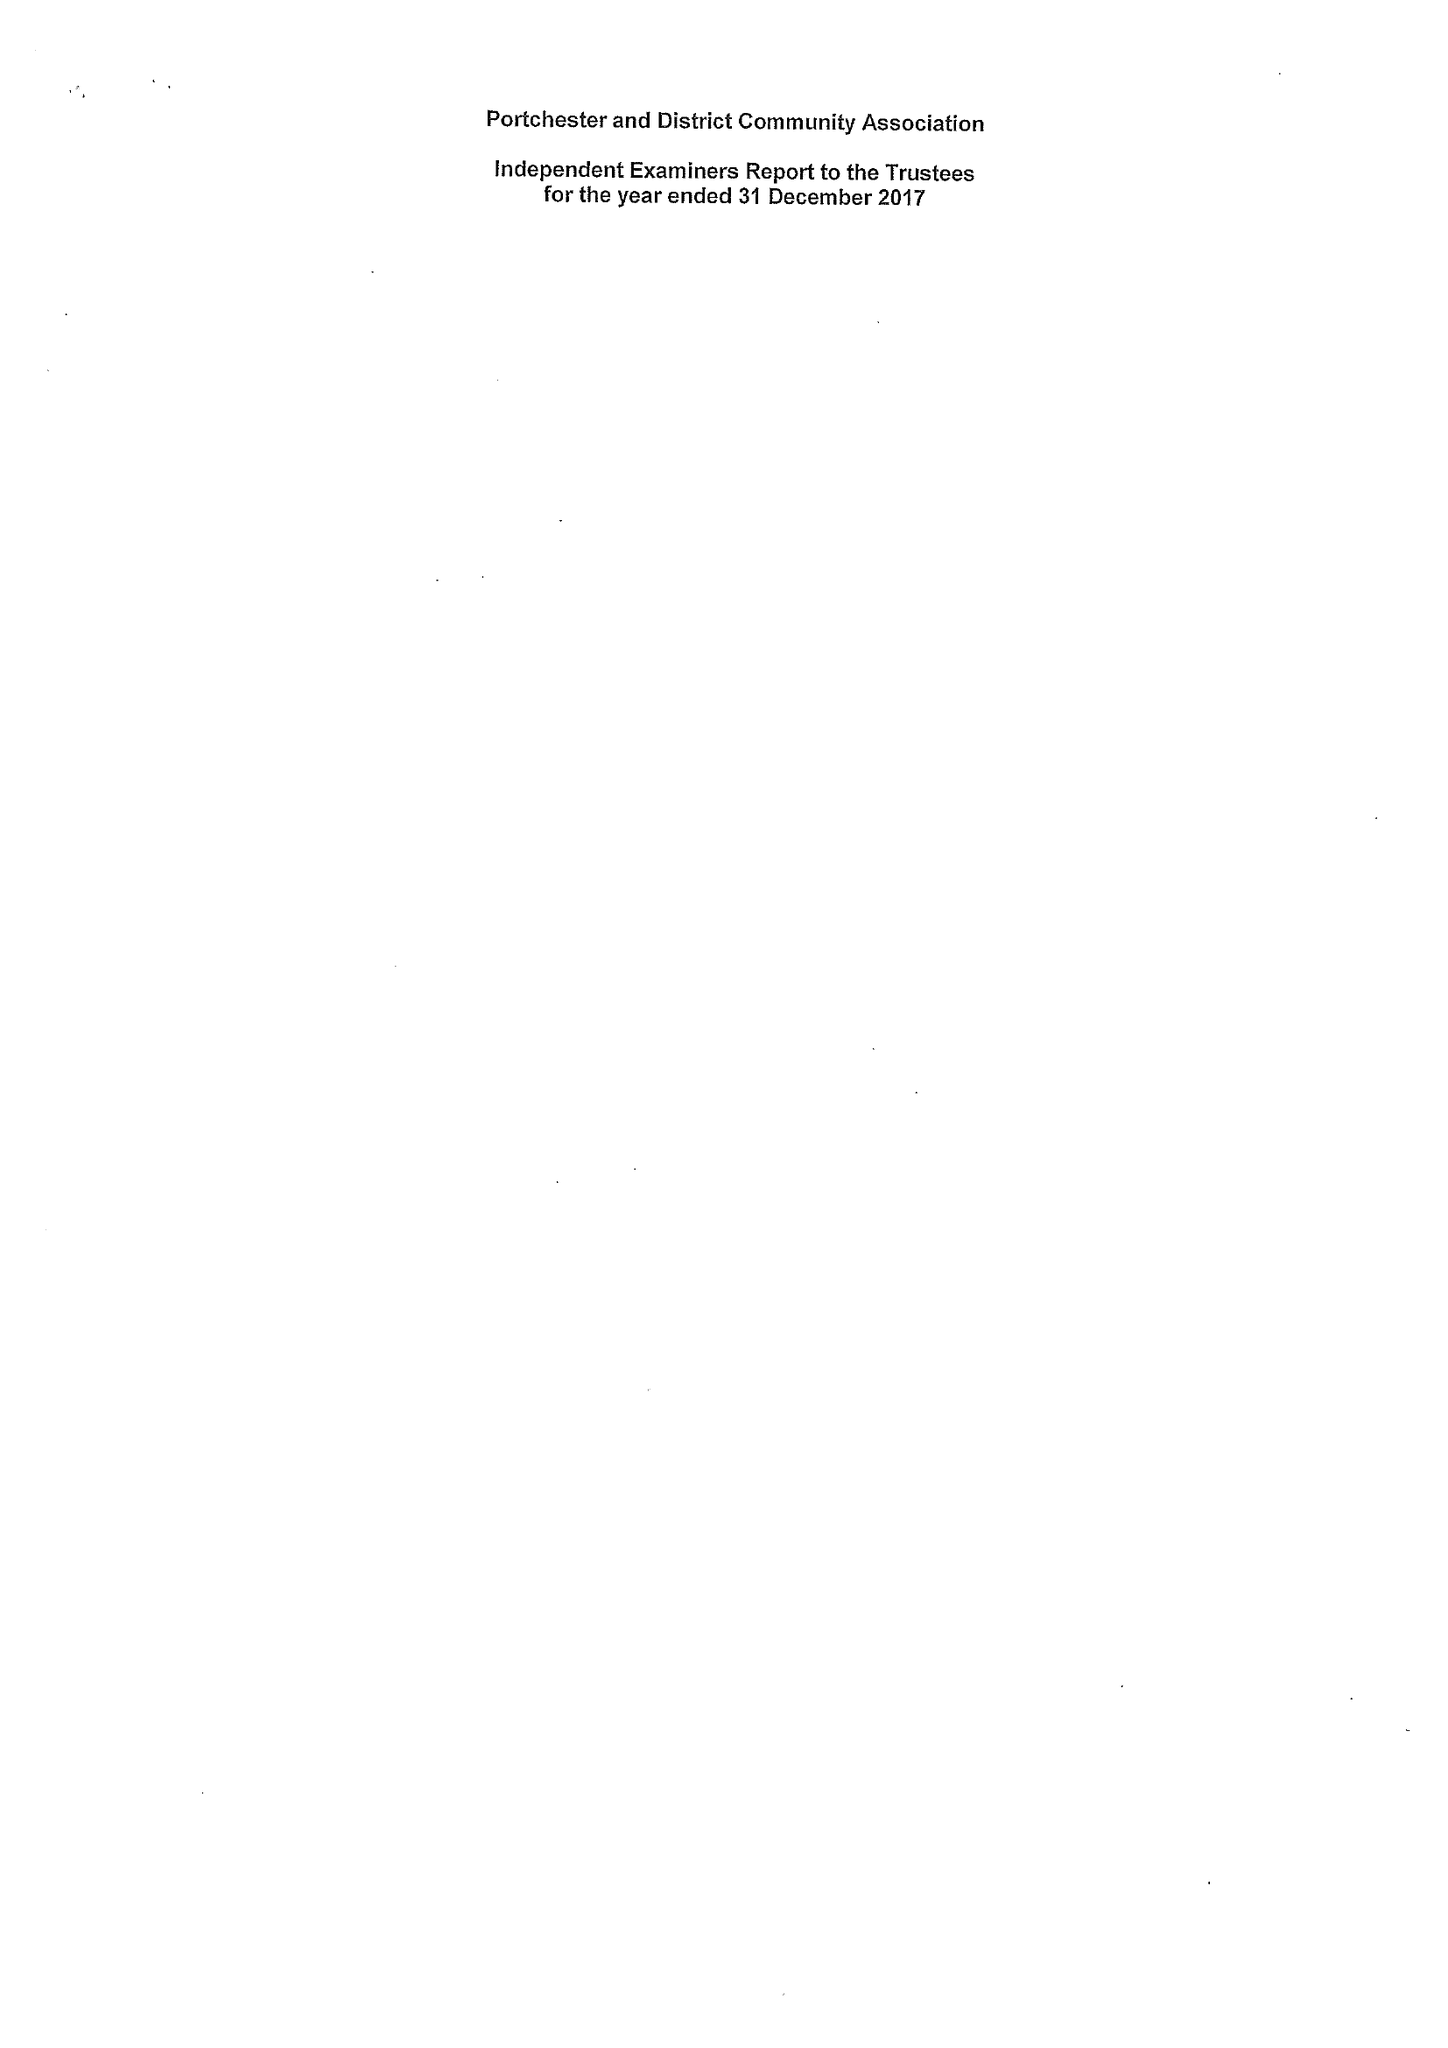What is the value for the income_annually_in_british_pounds?
Answer the question using a single word or phrase. 150922.00 